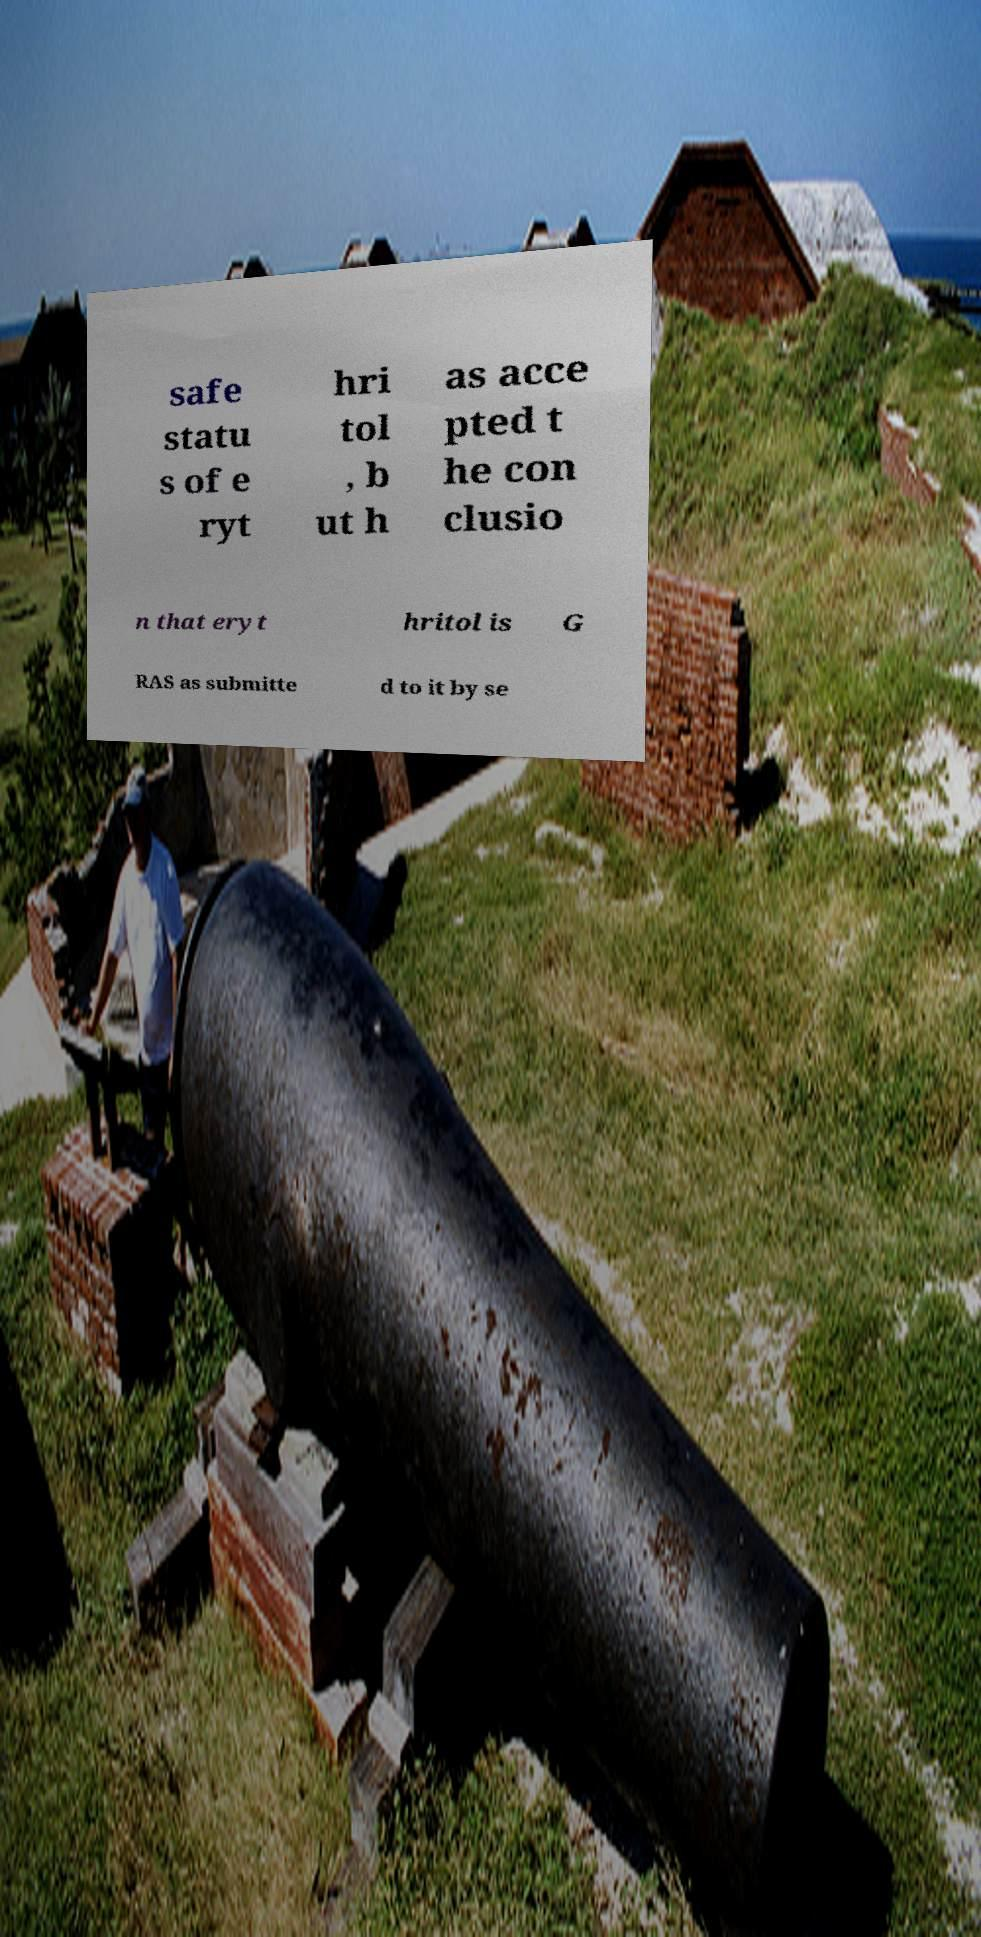Can you read and provide the text displayed in the image?This photo seems to have some interesting text. Can you extract and type it out for me? safe statu s of e ryt hri tol , b ut h as acce pted t he con clusio n that eryt hritol is G RAS as submitte d to it by se 